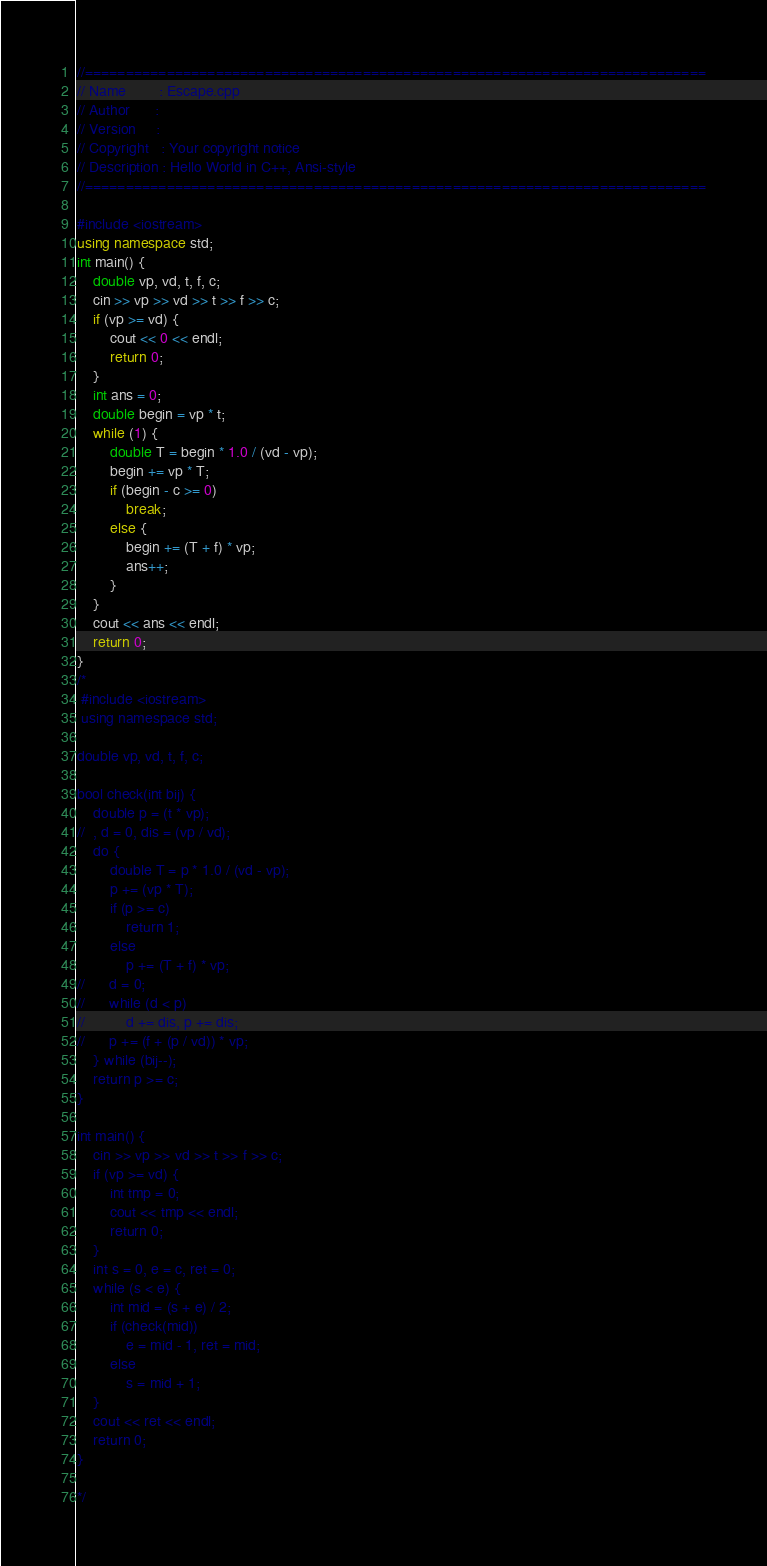<code> <loc_0><loc_0><loc_500><loc_500><_C++_>//============================================================================
// Name        : Escape.cpp
// Author      :
// Version     :
// Copyright   : Your copyright notice
// Description : Hello World in C++, Ansi-style
//============================================================================

#include <iostream>
using namespace std;
int main() {
	double vp, vd, t, f, c;
	cin >> vp >> vd >> t >> f >> c;
	if (vp >= vd) {
		cout << 0 << endl;
		return 0;
	}
	int ans = 0;
	double begin = vp * t;
	while (1) {
		double T = begin * 1.0 / (vd - vp);
		begin += vp * T;
		if (begin - c >= 0)
			break;
		else {
			begin += (T + f) * vp;
			ans++;
		}
	}
	cout << ans << endl;
	return 0;
}
/*
 #include <iostream>
 using namespace std;

double vp, vd, t, f, c;

bool check(int bij) {
	double p = (t * vp);
//	, d = 0, dis = (vp / vd);
	do {
		double T = p * 1.0 / (vd - vp);
		p += (vp * T);
		if (p >= c)
			return 1;
		else
			p += (T + f) * vp;
//		d = 0;
//		while (d < p)
//			d += dis, p += dis;
//		p += (f + (p / vd)) * vp;
	} while (bij--);
	return p >= c;
}

int main() {
	cin >> vp >> vd >> t >> f >> c;
	if (vp >= vd) {
		int tmp = 0;
		cout << tmp << endl;
		return 0;
	}
	int s = 0, e = c, ret = 0;
	while (s < e) {
		int mid = (s + e) / 2;
		if (check(mid))
			e = mid - 1, ret = mid;
		else
			s = mid + 1;
	}
	cout << ret << endl;
	return 0;
}

*/
</code> 